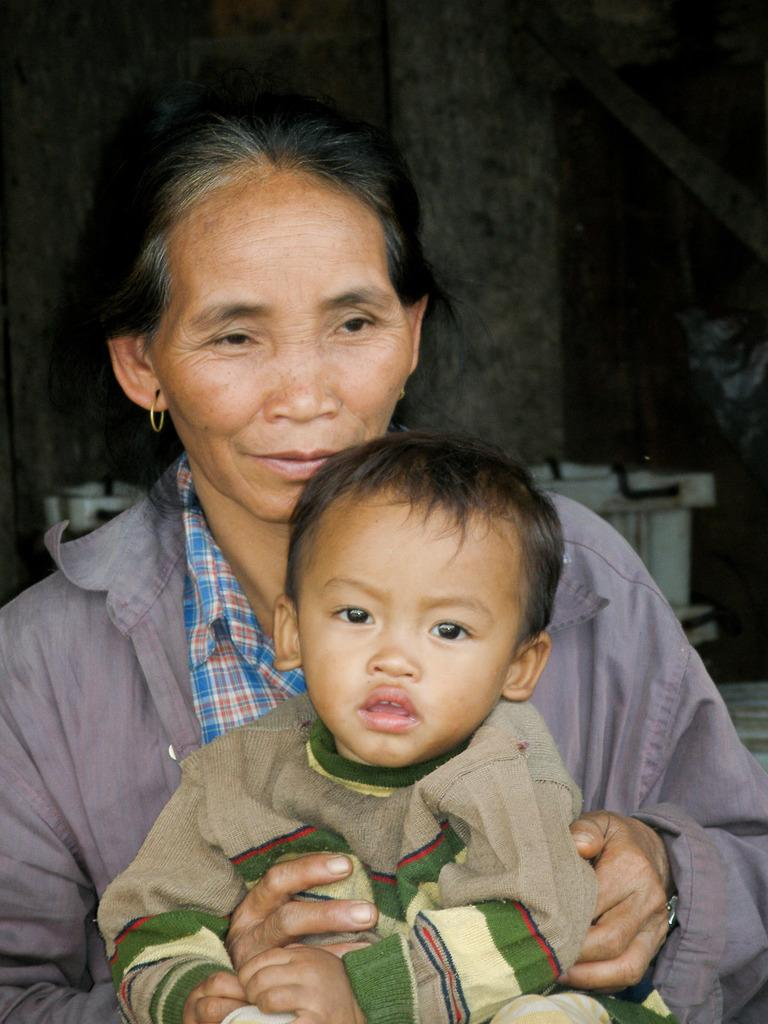What is present in the image? There is a woman in the image. What is the woman doing in the image? The woman is holding a boy. Can you describe the background of the image? There are objects in the background of the image. What color is the bean in the image? There is no bean present in the image. How many eyes can be seen on the net in the image? There is no net or any reference to eyes in the image. 